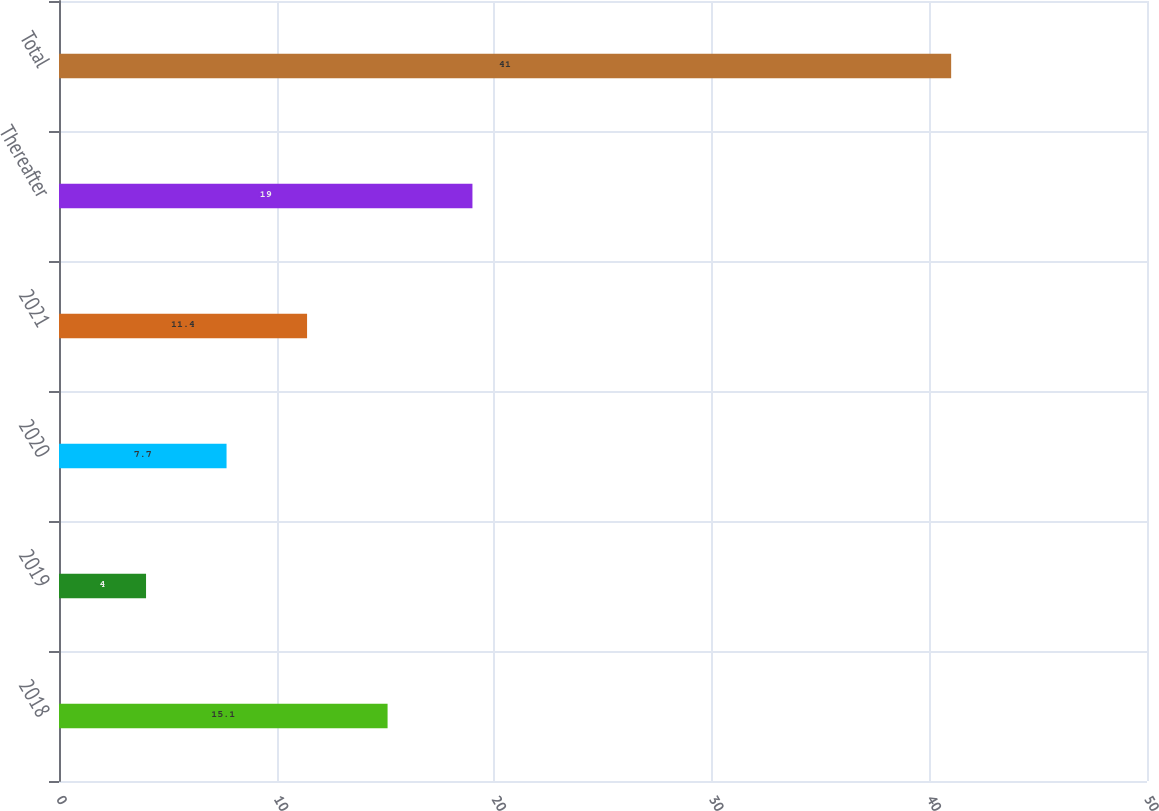Convert chart to OTSL. <chart><loc_0><loc_0><loc_500><loc_500><bar_chart><fcel>2018<fcel>2019<fcel>2020<fcel>2021<fcel>Thereafter<fcel>Total<nl><fcel>15.1<fcel>4<fcel>7.7<fcel>11.4<fcel>19<fcel>41<nl></chart> 